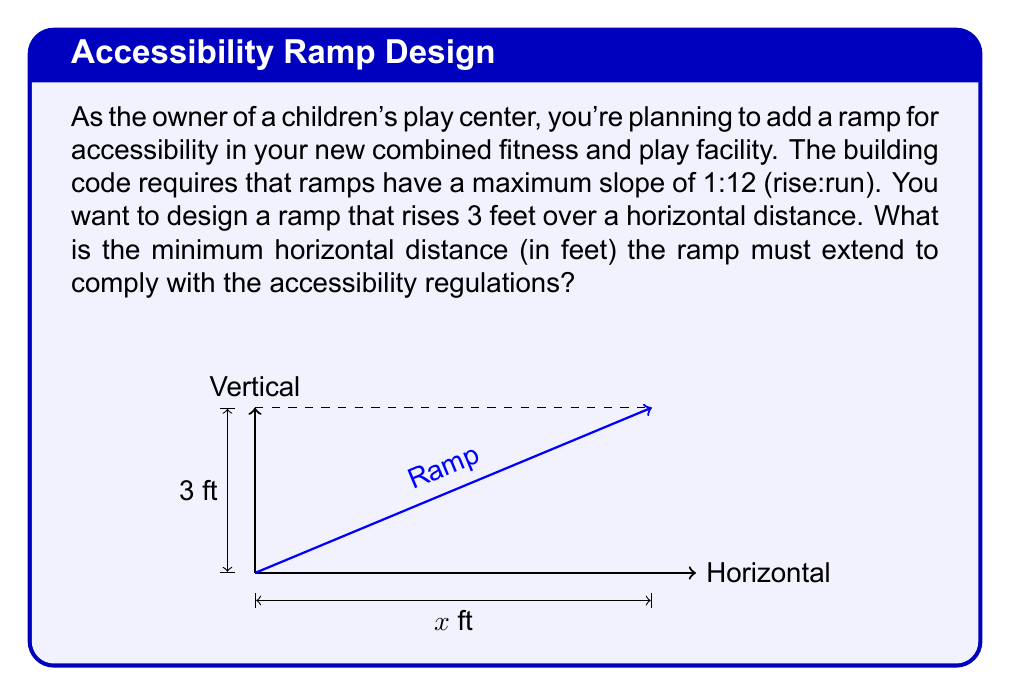Show me your answer to this math problem. Let's approach this step-by-step:

1) The slope requirement of 1:12 means that for every 1 unit of rise, there must be at least 12 units of run.

2) We can express this as a slope equation:

   $$\text{Slope} = \frac{\text{Rise}}{\text{Run}} \leq \frac{1}{12}$$

3) In our case, we know the rise is 3 feet. Let's call the unknown run $x$ feet. We can set up the inequality:

   $$\frac{3}{x} \leq \frac{1}{12}$$

4) To solve for $x$, we can cross-multiply:

   $$3 \cdot 12 \leq 1 \cdot x$$
   $$36 \leq x$$

5) Therefore, the run (horizontal distance) must be at least 36 feet to comply with the slope requirement.

6) To verify, we can check the slope:

   $$\frac{3 \text{ ft}}{36 \text{ ft}} = \frac{1}{12}$$

   This equals the maximum allowed slope, confirming our calculation.
Answer: 36 feet 